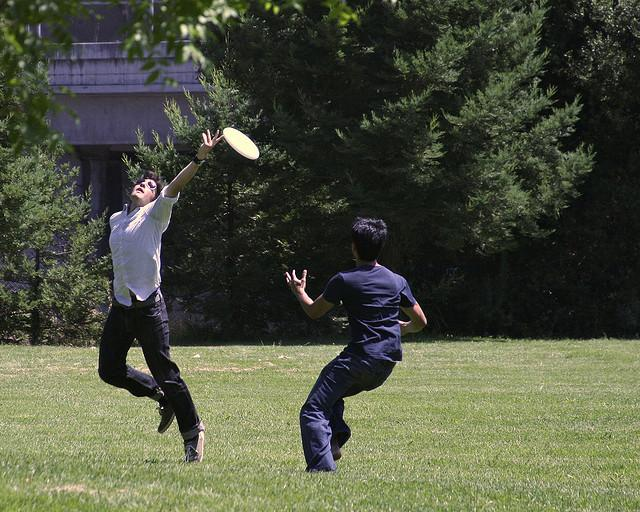The man in the white shirt is using what to touch the frisbee? finger 